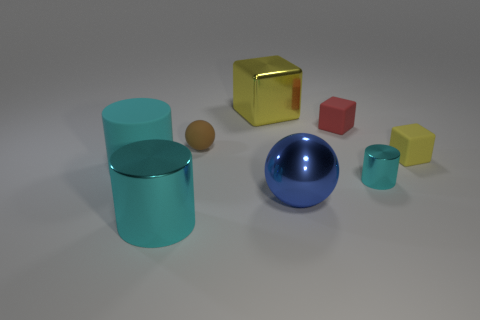What could the arrangement of these objects represent or symbolize? The arrangement of the objects might represent diversity and order, with various geometric shapes such as cylinders, cubes, and spheres showing harmonious coexistence despite differences in form and color. This could symbolize a concept like diversity within unity or the variety of experiences in a well-ordered system. 